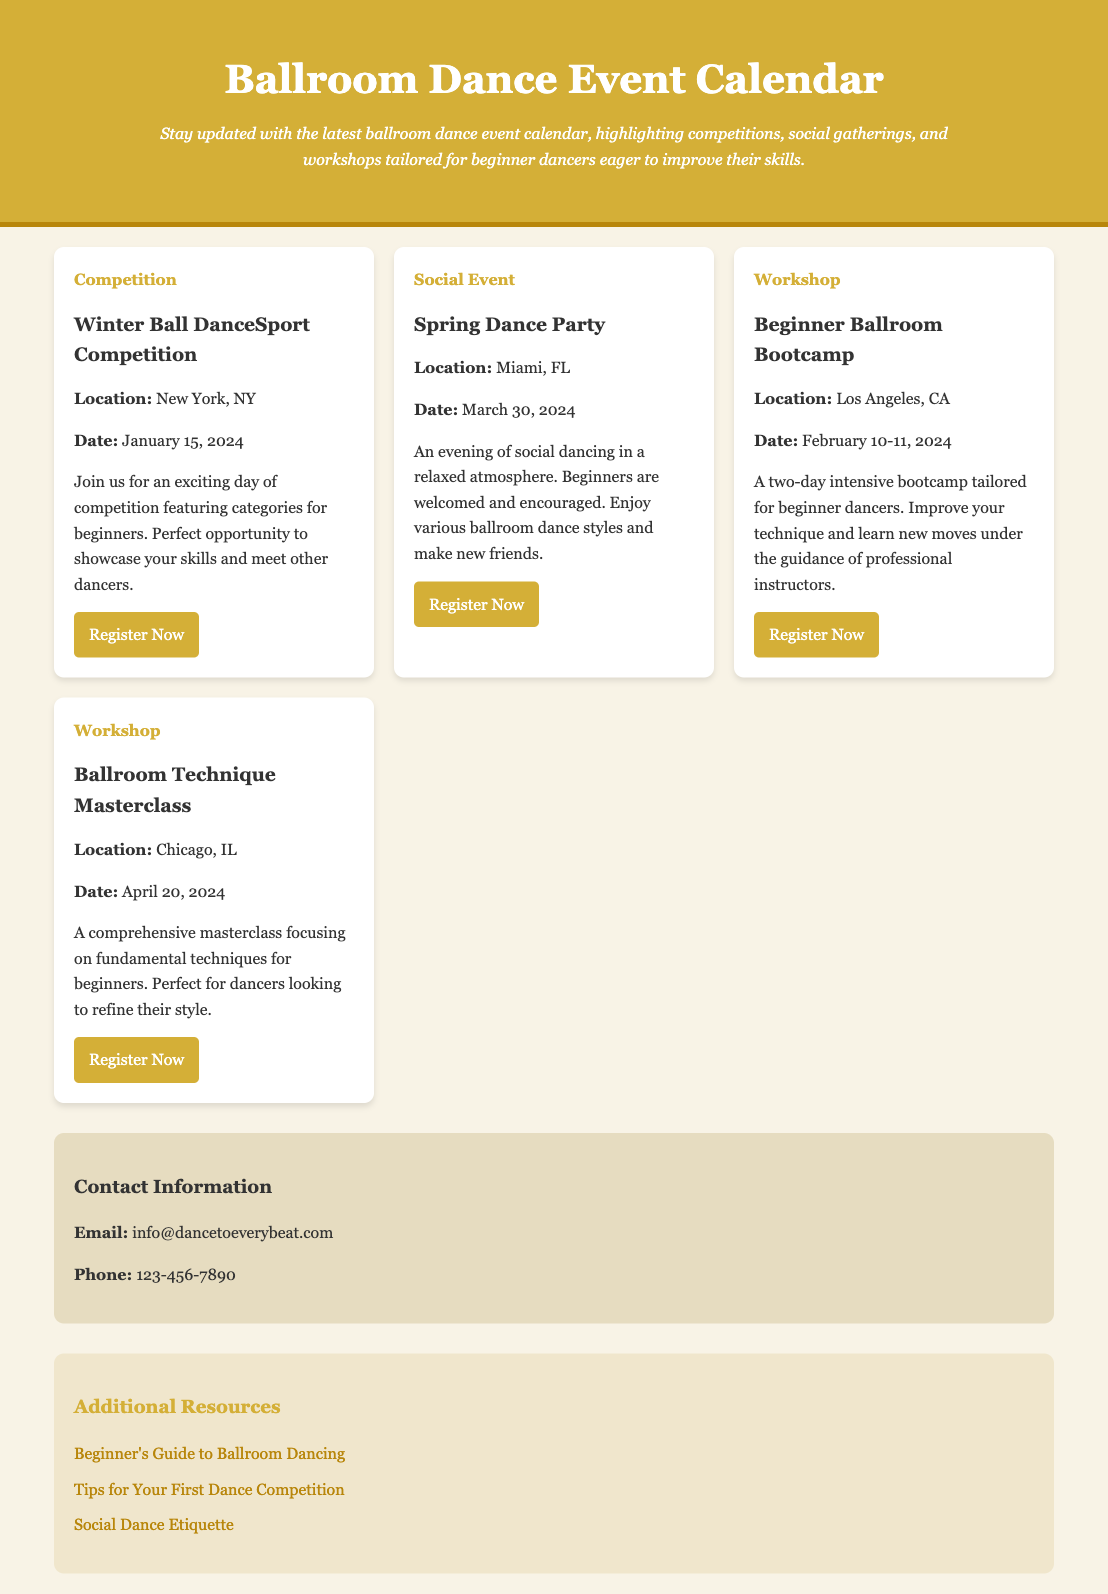What is the title of the first event? The title of the first event is located in the event card for the competition section.
Answer: Winter Ball DanceSport Competition When is the Spring Dance Party scheduled? The date of the Spring Dance Party can be found in the event card description for the social event.
Answer: March 30, 2024 What city will the Beginner Ballroom Bootcamp be held in? The location of the Beginner Ballroom Bootcamp is specified in the event card for the workshop section.
Answer: Los Angeles, CA How many days does the Beginner Ballroom Bootcamp last? The length of the Beginner Ballroom Bootcamp is mentioned in the event details within the workshop card.
Answer: Two days Which type of event is scheduled for April 20, 2024? The type of event on that date can be identified from the event card details related to that date.
Answer: Workshop What is the email for contacting the event organizer? The contact information section provides specific contact details for inquiries.
Answer: info@dancetoeverybeat.com What is a recommended resource for beginner dancers? The resources section lists several helpful links for beginners.
Answer: Beginner's Guide to Ballroom Dancing What can participants expect at the Winter Ball DanceSport Competition? The event details explain what attendees can expect during that competition.
Answer: Exciting day of competition featuring categories for beginners 